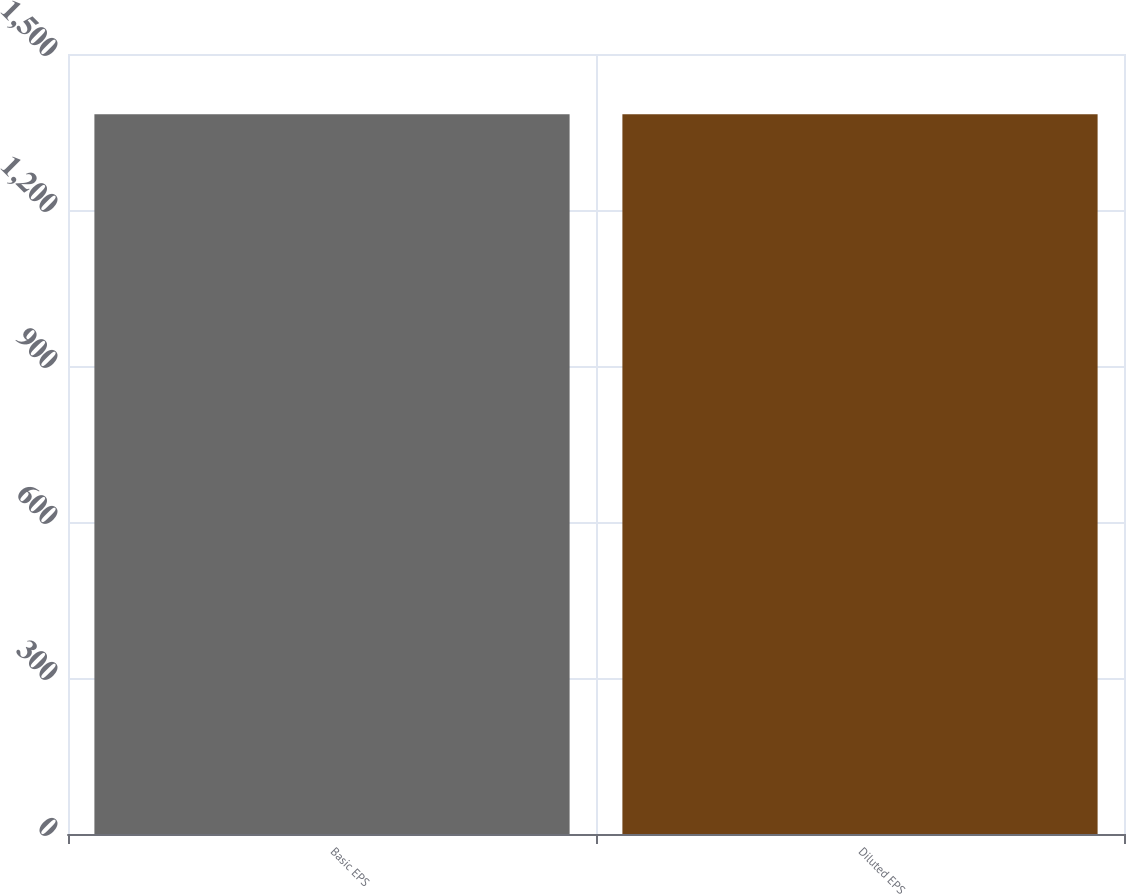<chart> <loc_0><loc_0><loc_500><loc_500><bar_chart><fcel>Basic EPS<fcel>Diluted EPS<nl><fcel>1384<fcel>1384.1<nl></chart> 